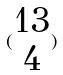<formula> <loc_0><loc_0><loc_500><loc_500>( \begin{matrix} 1 3 \\ 4 \end{matrix} )</formula> 